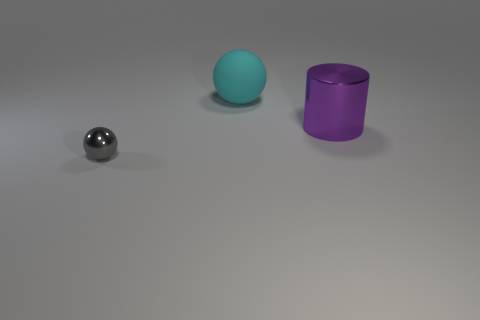What shape is the gray object?
Your answer should be compact. Sphere. Do the metal cylinder and the gray shiny thing have the same size?
Keep it short and to the point. No. What number of other things are there of the same shape as the big purple object?
Make the answer very short. 0. There is a big thing behind the purple object; what shape is it?
Provide a succinct answer. Sphere. Is the shape of the shiny object on the right side of the small metal ball the same as the object to the left of the cyan thing?
Keep it short and to the point. No. Are there an equal number of gray metal things that are in front of the small shiny sphere and large purple metallic objects?
Offer a terse response. No. Are there any other things that have the same size as the gray thing?
Provide a short and direct response. No. What is the material of the other object that is the same shape as the tiny metal object?
Offer a terse response. Rubber. There is a shiny thing that is behind the sphere in front of the metallic cylinder; what is its shape?
Keep it short and to the point. Cylinder. Is the ball that is behind the tiny gray metallic object made of the same material as the big purple thing?
Give a very brief answer. No. 